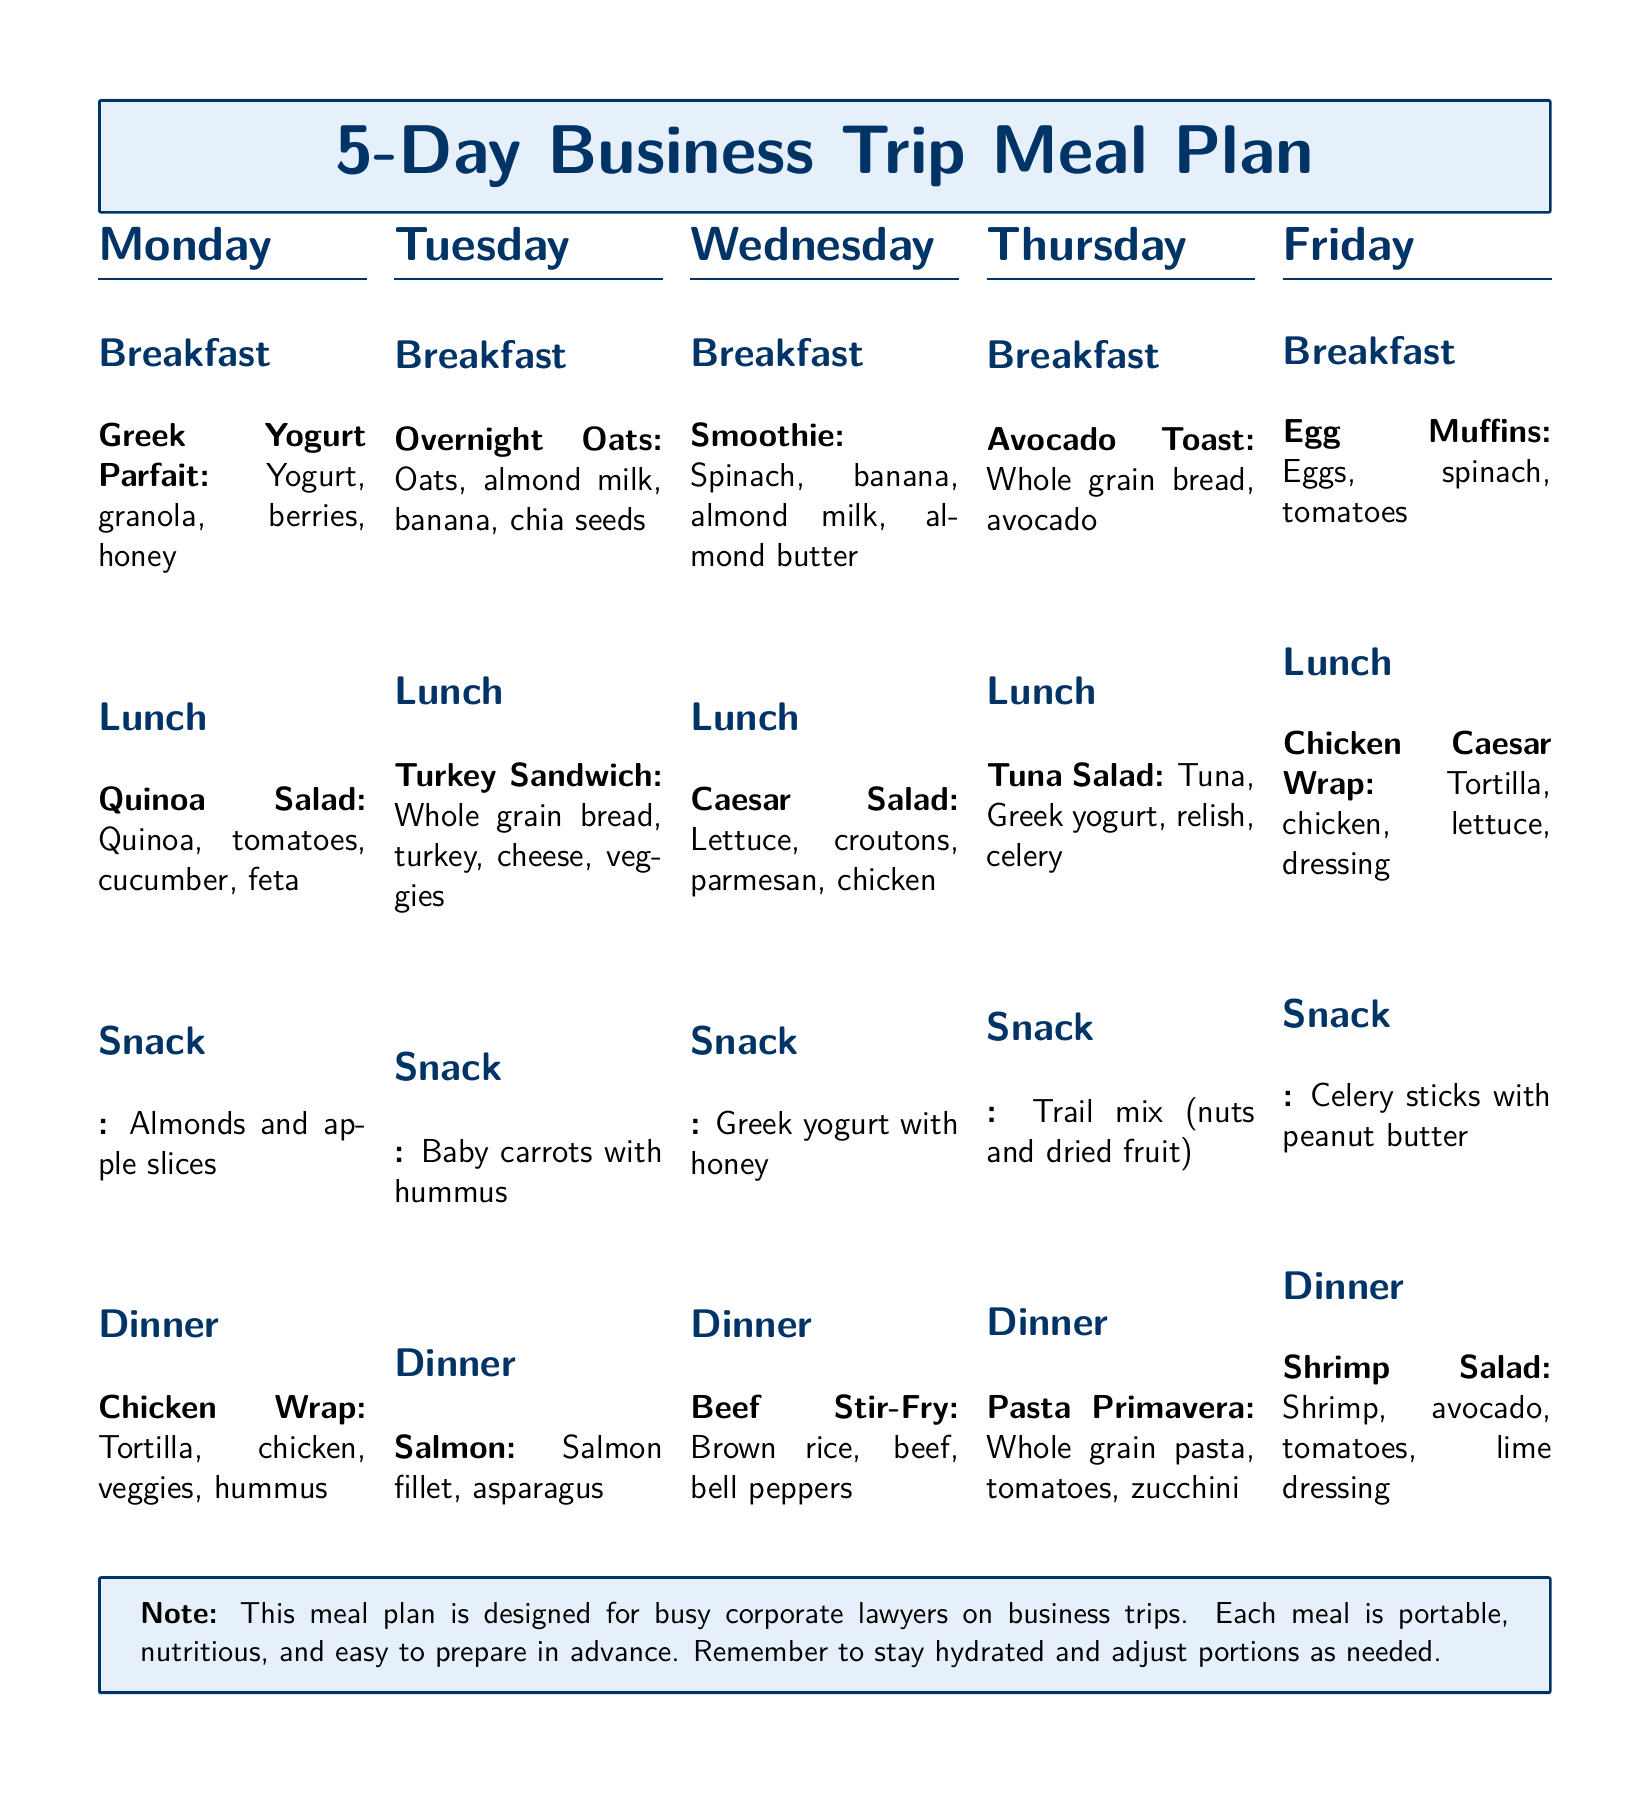What is the breakfast item for Monday? The breakfast item for Monday is listed under that day and specifies what it consists of.
Answer: Greek Yogurt Parfait What is the main ingredient in the Tuesday lunch? The Tuesday lunch meal item identifies the main ingredient used in the sandwich.
Answer: Turkey What snack is suggested for Thursday? The snack for Thursday is explicitly mentioned in the document as a specific type of food.
Answer: Trail mix (nuts and dried fruit) What type of meal is served on Friday for dinner? The Friday dinner meal item describes the specific type of dish that is being served.
Answer: Shrimp Salad How many meals are included in the plan for a single day? The document outlines the meal structure for each day, noting how many meals are provided.
Answer: Four Which day includes a smoothie for breakfast? The breakfast item on that particular day clearly states the meal and the ingredients.
Answer: Wednesday What food group is prominent in the Monday lunch? The items listed for lunch describe a specific food group mainly featured that day.
Answer: Vegetables What is the total number of days covered in the meal plan? The document plainly states the duration for which the meal ideas are structured without ambiguity.
Answer: Five 